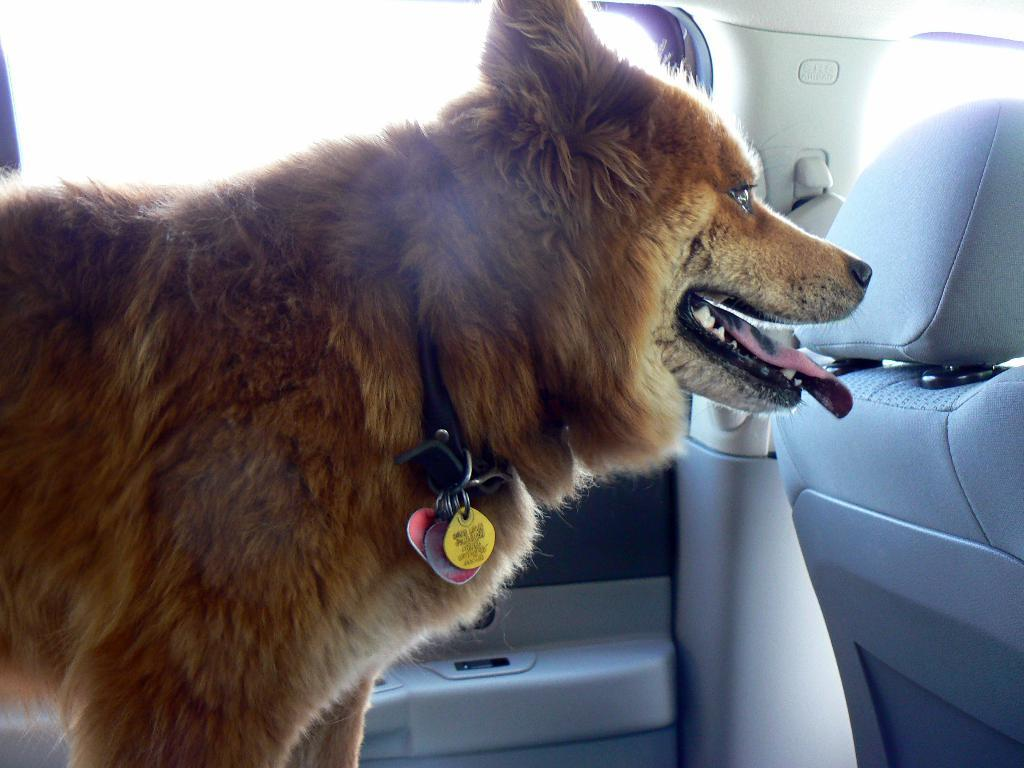What animal can be seen in the image? There is a dog in the image. Where is the dog located? The dog is standing inside a car. What type of window is visible in the image? There is a glass window visible in the image. What items are associated with the dog in the image? There are plastic things (possibly a neck belt) associated with the dog. What type of crook can be seen in the image? There is no crook present in the image; it features a dog standing inside a car. What facial expression does the dog have in the image? The image does not show the dog's face, so it is impossible to determine its facial expression. 